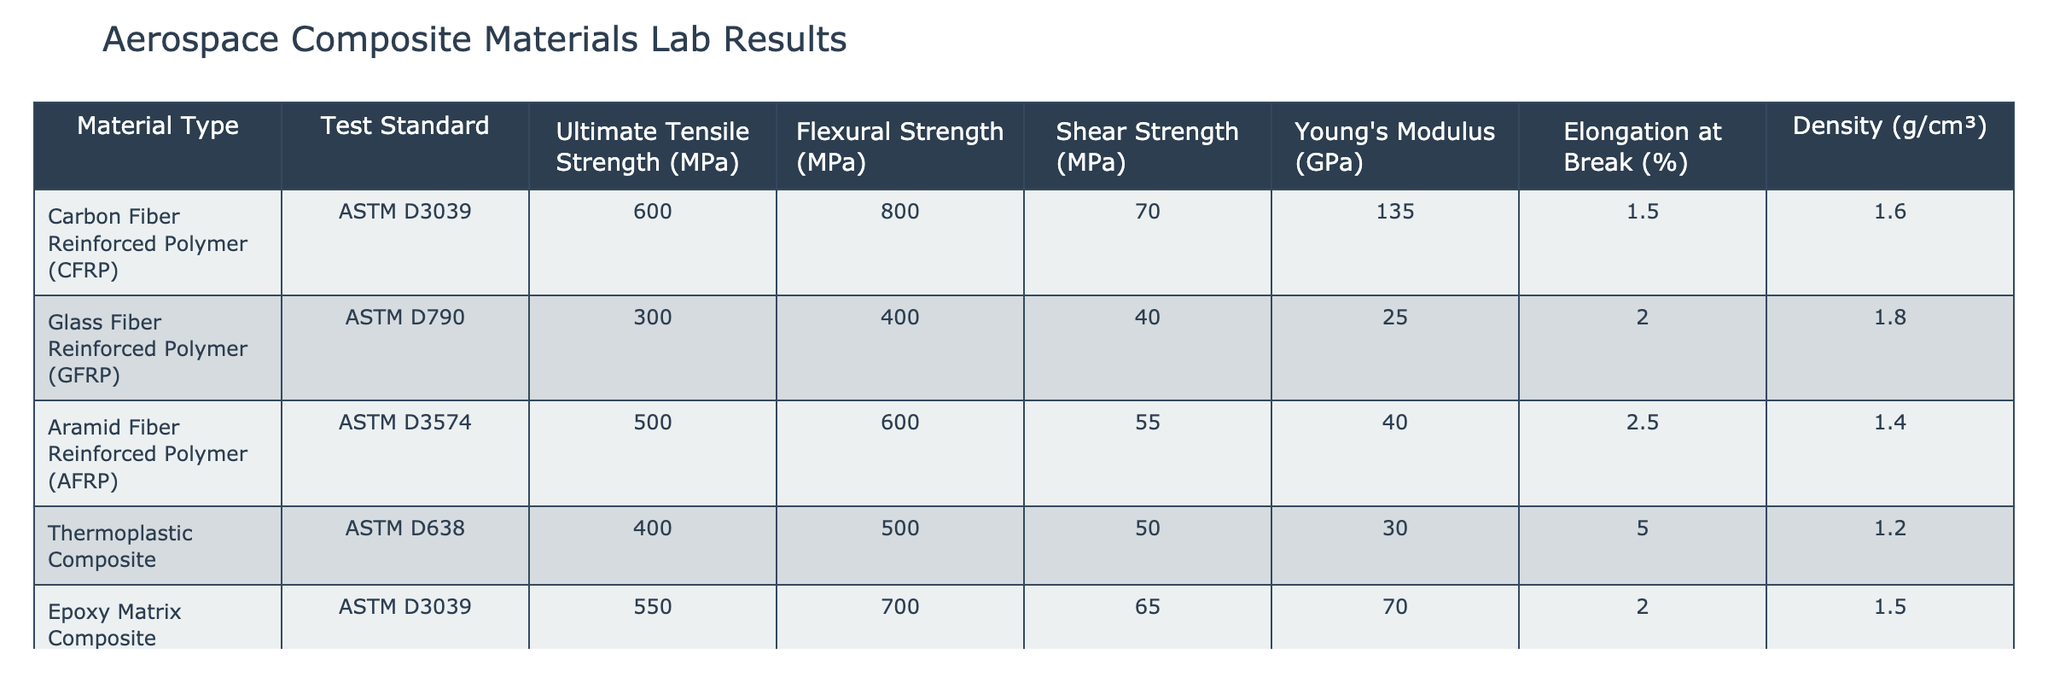What is the Ultimate Tensile Strength of Carbon Fiber Reinforced Polymer (CFRP)? The table indicates that the Ultimate Tensile Strength for CFRP is specifically listed under the corresponding column. Referring to the table, the value is 600 MPa.
Answer: 600 MPa How does the Flexural Strength of Glass Fiber Reinforced Polymer (GFRP) compare to that of Aramid Fiber Reinforced Polymer (AFRP)? The Flexural Strength of GFRP is 400 MPa, while that of AFRP is 600 MPa. Comparing the two, AFRP has a higher Flexural Strength by 200 MPa (600 - 400 = 200).
Answer: AFRP has higher Flexural Strength by 200 MPa Is the Density of Thermoplastic Composite higher than that of Hybrid Fiber Composite? The Density of Thermoplastic Composite is 1.2 g/cm³, and the Density of Hybrid Fiber Composite is 1.6 g/cm³. Since 1.2 is not greater than 1.6, this statement is false.
Answer: No What is the average Young's Modulus for all the materials tested? To calculate the average Young's Modulus, we need to sum the Young's Modulus of all materials: (135 + 25 + 40 + 30 + 70 + 50) = 350 GPa. Then, we divide by the number of materials (6): 350 / 6 = 58.33 GPa.
Answer: 58.33 GPa Which material type has the highest Elongation at Break? To find the highest Elongation at Break, we examine the values listed for all material types: 1.5%, 2.0%, 2.5%, 5.0%, 2.0%, and 3.5%. The highest value is 5.0% for Thermoplastic Composite.
Answer: Thermoplastic Composite has the highest Elongation at Break at 5.0% What is the difference in Shear Strength between the lowest and highest values? The lowest Shear Strength in the table is 40 MPa (GFRP), and the highest is 70 MPa (CFRP). The difference is 70 - 40 = 30 MPa.
Answer: 30 MPa Is there any material that has both Flexural Strength and Shear Strength above 500 MPa? Checking the table, only CFRP and AFRP have Flexural Strength above 500 MPa (800 MPa and 600 MPa respectively), while neither has Shear Strength above 500 MPa. Therefore, the statement is false.
Answer: No What is the Young's Modulus of Glass Fiber Reinforced Polymer (GFRP)? The Young's Modulus for GFRP is explicitly stated as 25 GPa in the table. This value is found directly under the Young's Modulus column for GFRP.
Answer: 25 GPa 